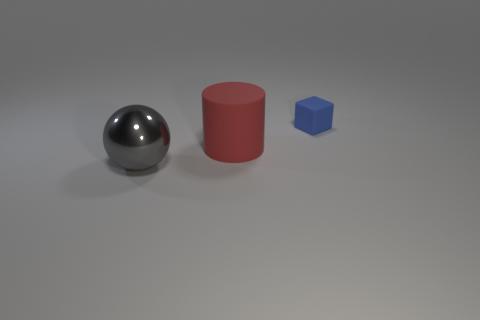Add 3 large blue metal spheres. How many objects exist? 6 Subtract all spheres. How many objects are left? 2 Subtract all gray objects. Subtract all red cylinders. How many objects are left? 1 Add 2 large gray spheres. How many large gray spheres are left? 3 Add 2 big red rubber objects. How many big red rubber objects exist? 3 Subtract 0 yellow balls. How many objects are left? 3 